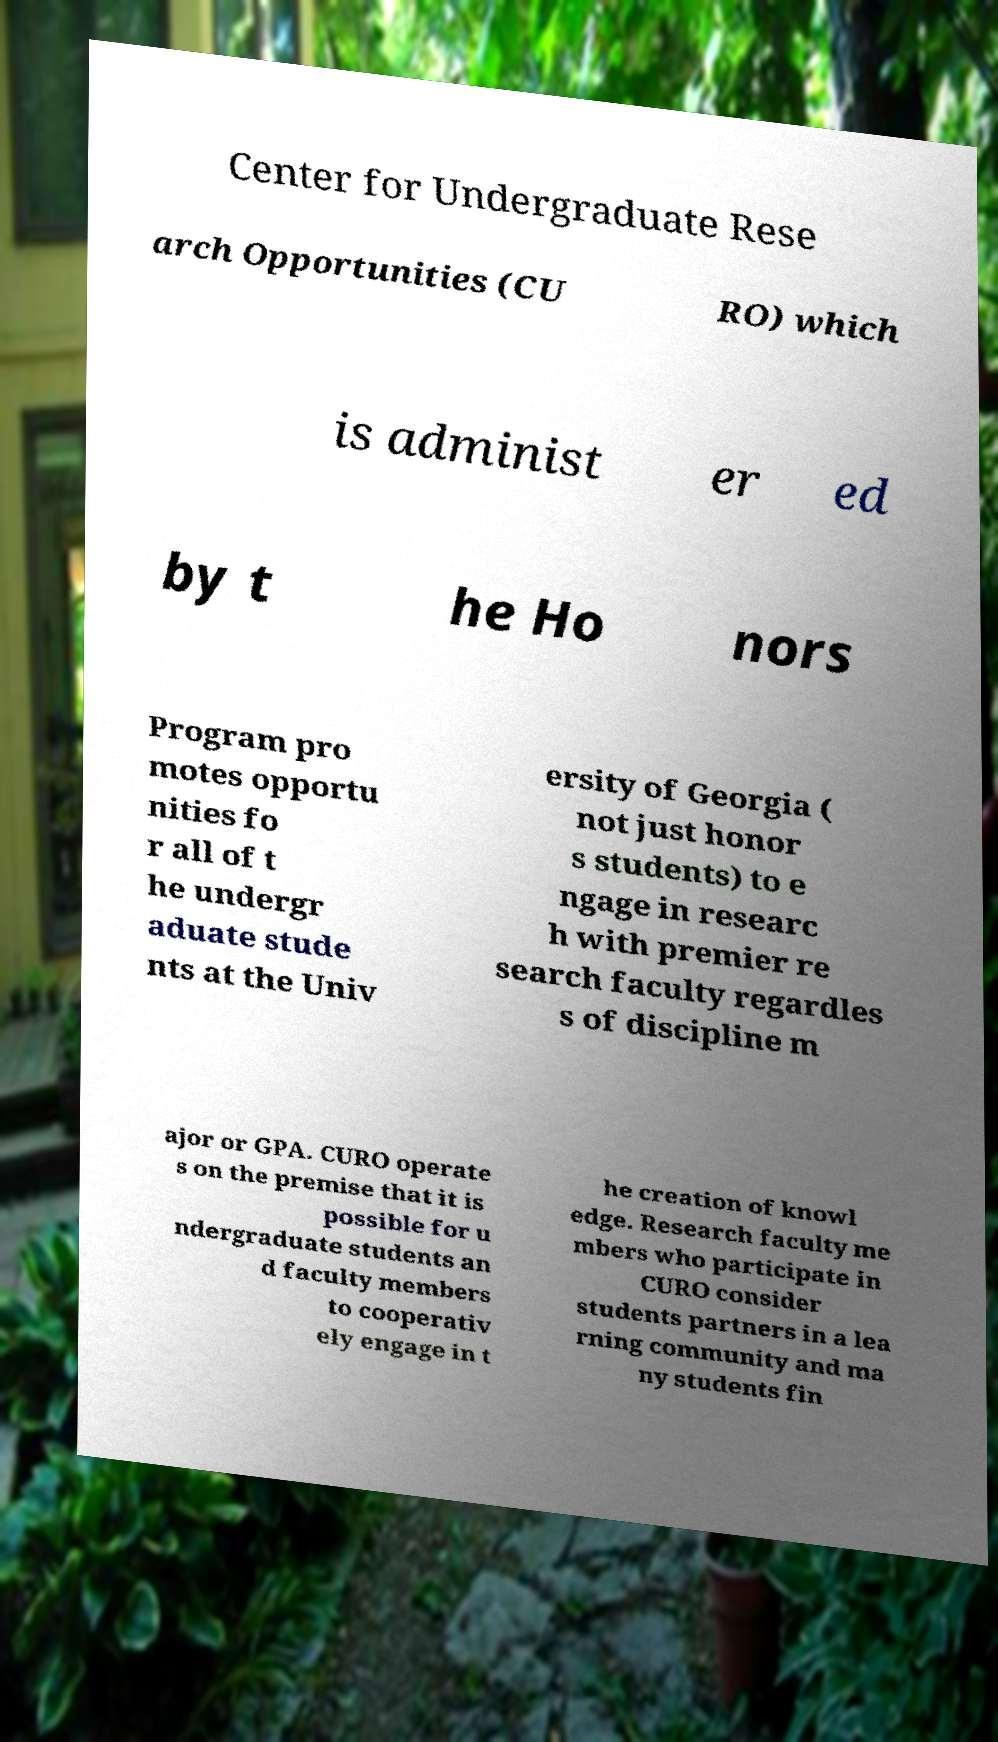Can you accurately transcribe the text from the provided image for me? Center for Undergraduate Rese arch Opportunities (CU RO) which is administ er ed by t he Ho nors Program pro motes opportu nities fo r all of t he undergr aduate stude nts at the Univ ersity of Georgia ( not just honor s students) to e ngage in researc h with premier re search faculty regardles s of discipline m ajor or GPA. CURO operate s on the premise that it is possible for u ndergraduate students an d faculty members to cooperativ ely engage in t he creation of knowl edge. Research faculty me mbers who participate in CURO consider students partners in a lea rning community and ma ny students fin 